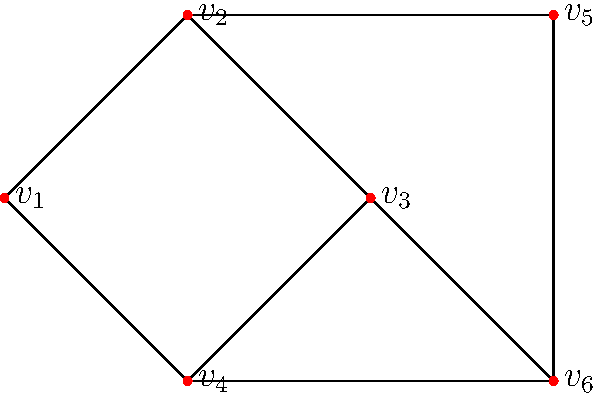Given the network graph above, what is the minimum number of edges that need to be removed to disconnect the graph into two or more components? To solve this problem, we need to understand the concept of edge connectivity in graph theory. The edge connectivity of a graph is the minimum number of edges that need to be removed to disconnect the graph.

Let's approach this step-by-step:

1. First, we need to identify all possible paths between any two vertices in the graph.

2. We observe that there are multiple paths between most pairs of vertices. For example, between $v_1$ and $v_6$, we have:
   - $v_1 - v_2 - v_5 - v_6$
   - $v_1 - v_4 - v_6$
   - $v_1 - v_2 - v_3 - v_6$

3. To disconnect the graph, we need to cut all possible paths between at least one pair of vertices.

4. Looking at the graph structure, we can see that removing any single edge will not disconnect the graph, as there will always be alternative paths.

5. However, if we remove two specific edges, we can disconnect the graph. The minimum cut would be removing the edges $(v_2, v_3)$ and $(v_4, v_6)$.

6. Removing these two edges would separate vertex $v_3$ from the rest of the graph, creating two components.

7. There is no way to disconnect the graph by removing only one edge, so two is the minimum number.

Therefore, the edge connectivity of this graph is 2, which is the answer to our question.
Answer: 2 